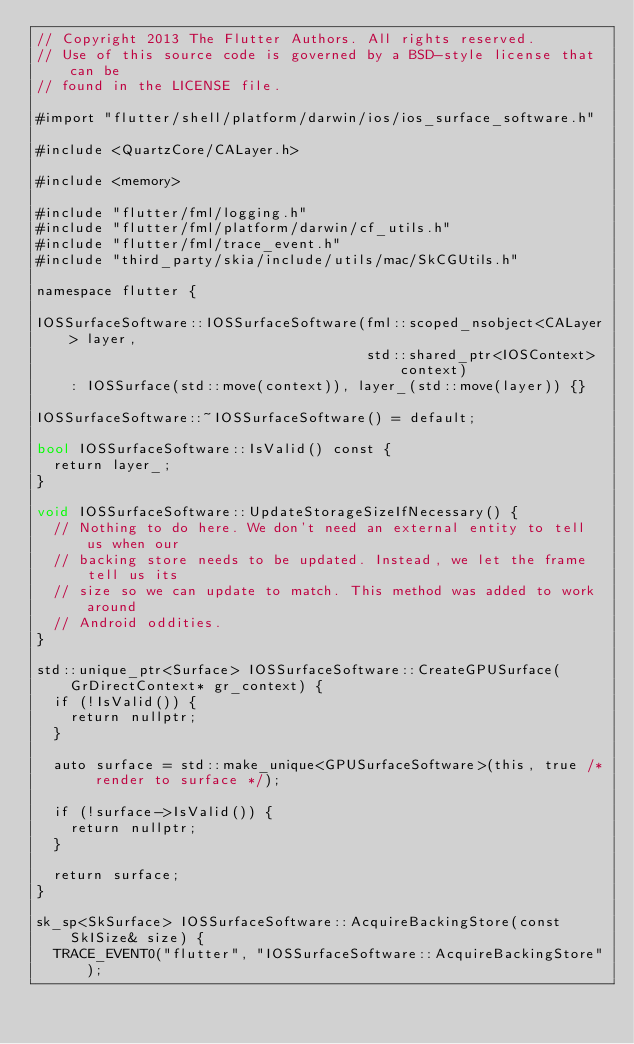<code> <loc_0><loc_0><loc_500><loc_500><_ObjectiveC_>// Copyright 2013 The Flutter Authors. All rights reserved.
// Use of this source code is governed by a BSD-style license that can be
// found in the LICENSE file.

#import "flutter/shell/platform/darwin/ios/ios_surface_software.h"

#include <QuartzCore/CALayer.h>

#include <memory>

#include "flutter/fml/logging.h"
#include "flutter/fml/platform/darwin/cf_utils.h"
#include "flutter/fml/trace_event.h"
#include "third_party/skia/include/utils/mac/SkCGUtils.h"

namespace flutter {

IOSSurfaceSoftware::IOSSurfaceSoftware(fml::scoped_nsobject<CALayer> layer,
                                       std::shared_ptr<IOSContext> context)
    : IOSSurface(std::move(context)), layer_(std::move(layer)) {}

IOSSurfaceSoftware::~IOSSurfaceSoftware() = default;

bool IOSSurfaceSoftware::IsValid() const {
  return layer_;
}

void IOSSurfaceSoftware::UpdateStorageSizeIfNecessary() {
  // Nothing to do here. We don't need an external entity to tell us when our
  // backing store needs to be updated. Instead, we let the frame tell us its
  // size so we can update to match. This method was added to work around
  // Android oddities.
}

std::unique_ptr<Surface> IOSSurfaceSoftware::CreateGPUSurface(GrDirectContext* gr_context) {
  if (!IsValid()) {
    return nullptr;
  }

  auto surface = std::make_unique<GPUSurfaceSoftware>(this, true /* render to surface */);

  if (!surface->IsValid()) {
    return nullptr;
  }

  return surface;
}

sk_sp<SkSurface> IOSSurfaceSoftware::AcquireBackingStore(const SkISize& size) {
  TRACE_EVENT0("flutter", "IOSSurfaceSoftware::AcquireBackingStore");</code> 